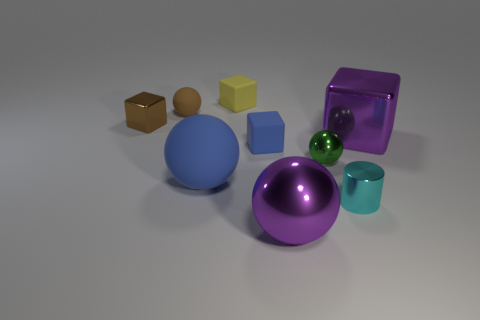Do the large metal thing that is on the left side of the tiny cyan cylinder and the matte thing that is left of the big blue matte sphere have the same shape? Yes, both objects have a cubic shape, featuring six faces with equal square dimensions. They both exhibit clear, straight edges and distinct vertices, which are characteristic traits of a cube or cuboid-like structure. 